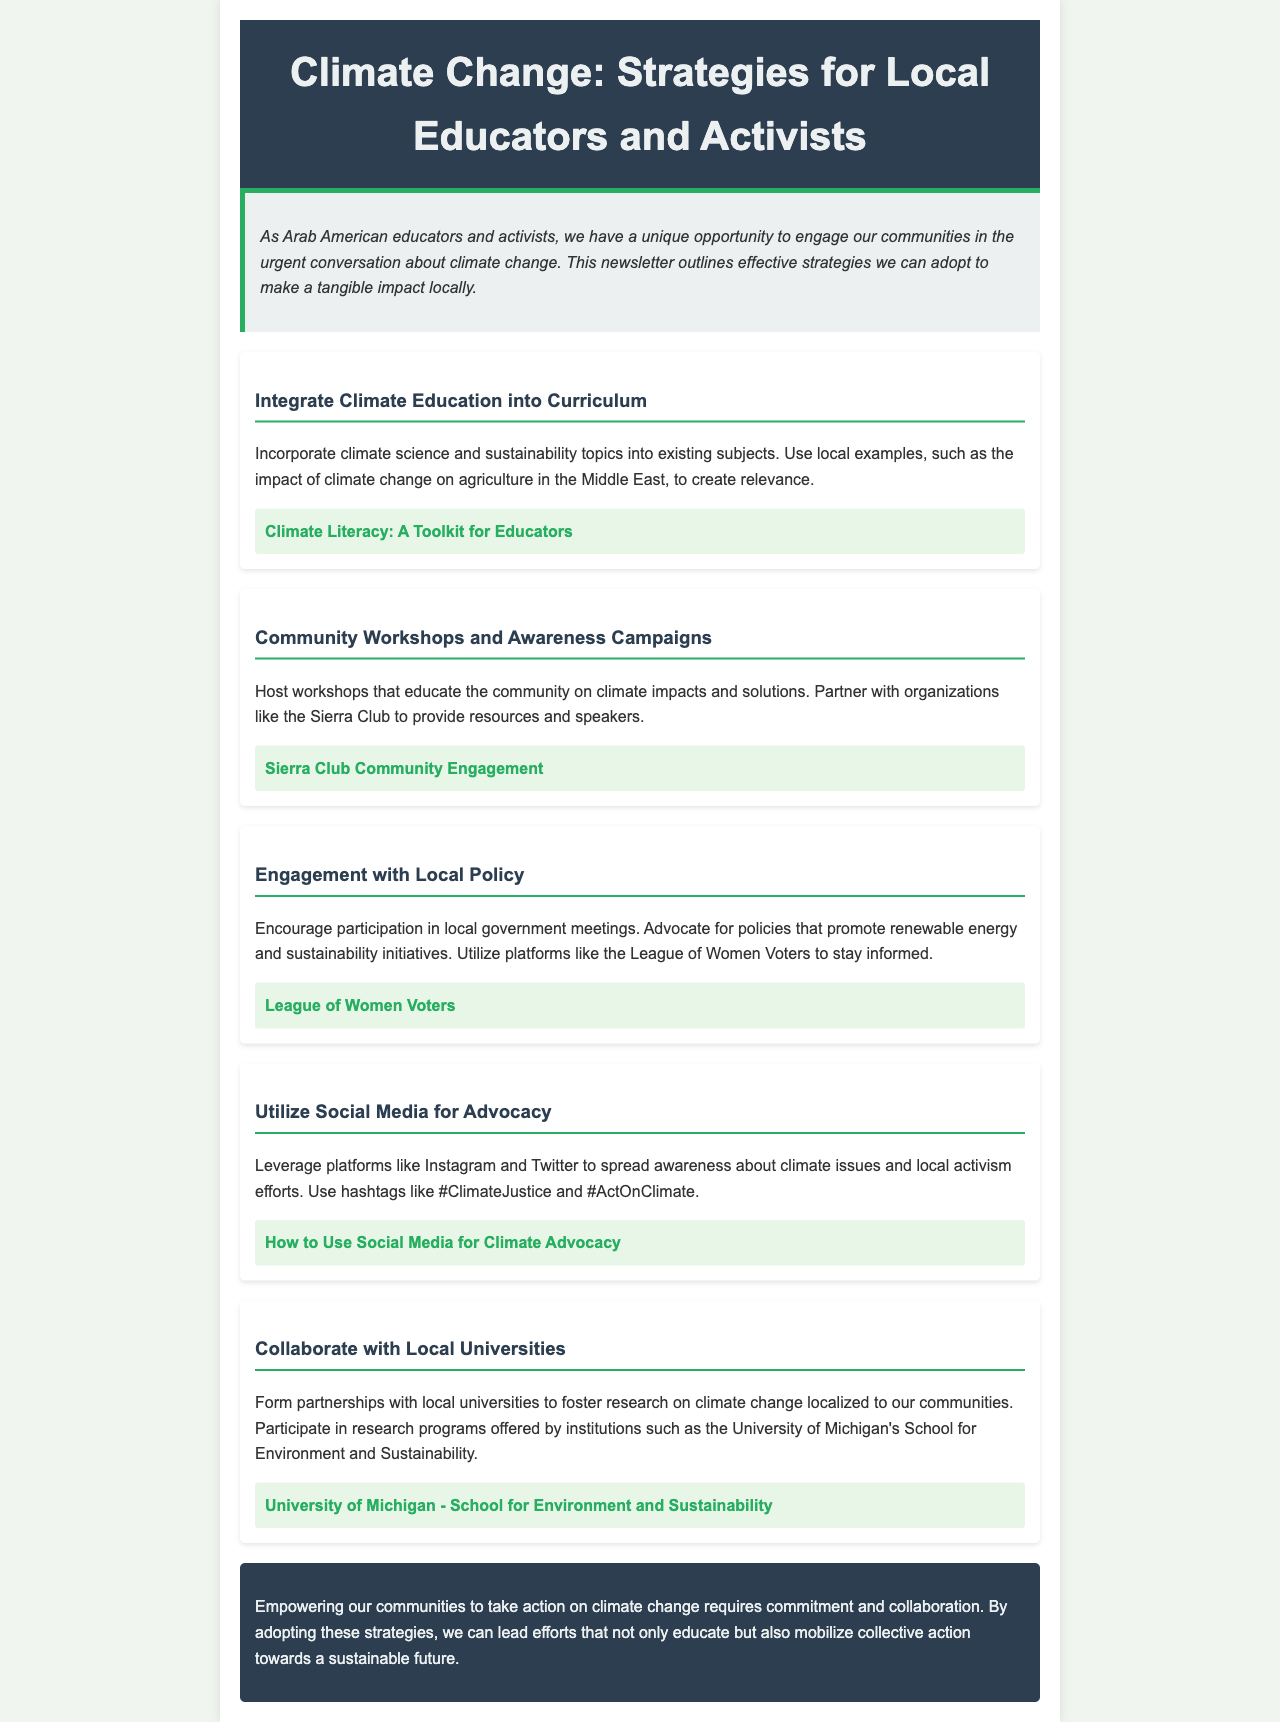What is the title of the newsletter? The title of the newsletter is stated in the header section of the document.
Answer: Climate Change: Strategies for Local Educators and Activists What aspect of climate change should be incorporated into the curriculum? The newsletter suggests incorporating climate science and sustainability topics into existing subjects for relevance.
Answer: Climate science and sustainability Which organization is recommended for community engagement? The document mentions an organization that can be partnered with to provide resources and speakers for workshops.
Answer: Sierra Club What social media platforms are suggested for climate advocacy? The newsletter lists specific platforms that can be used to spread awareness about climate issues.
Answer: Instagram and Twitter How many strategies are outlined in the newsletter? The newsletter includes a specific section that details the number of strategies provided.
Answer: Five What type of workshops is suggested in the newsletter? The newsletter emphasizes educational workshops focusing on climate impacts and solutions for the community.
Answer: Community Workshops Which university is mentioned for collaboration on climate change research? The document highlights a specific university known for its research on climate change localized to communities.
Answer: University of Michigan What is the main goal of the strategies outlined in the conclusion? The conclusion states the overall aim of implementing the specified strategies in the community.
Answer: Empowering communities What is a recommended resource for climate literacy? The newsletter provides a link to a specific toolkit that educators can use for climate education.
Answer: Climate Literacy: A Toolkit for Educators 